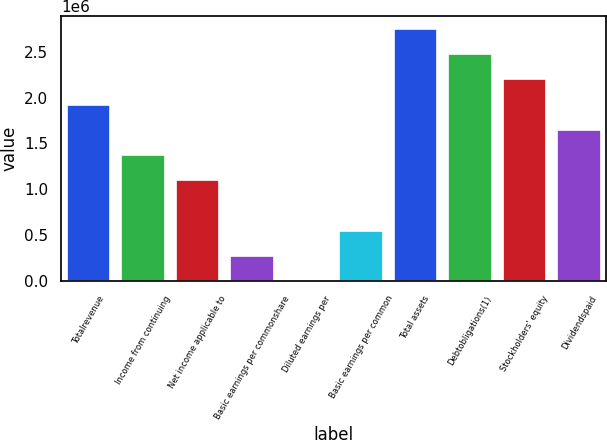<chart> <loc_0><loc_0><loc_500><loc_500><bar_chart><fcel>Totalrevenue<fcel>Income from continuing<fcel>Net income applicable to<fcel>Basic earnings per commonshare<fcel>Diluted earnings per<fcel>Basic earnings per common<fcel>Total assets<fcel>Debtobligations(1)<fcel>Stockholders' equity<fcel>Dividendspaid<nl><fcel>1.92389e+06<fcel>1.37421e+06<fcel>1.09937e+06<fcel>274843<fcel>0.9<fcel>549684<fcel>2.74842e+06<fcel>2.47358e+06<fcel>2.19873e+06<fcel>1.64905e+06<nl></chart> 